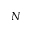Convert formula to latex. <formula><loc_0><loc_0><loc_500><loc_500>N</formula> 